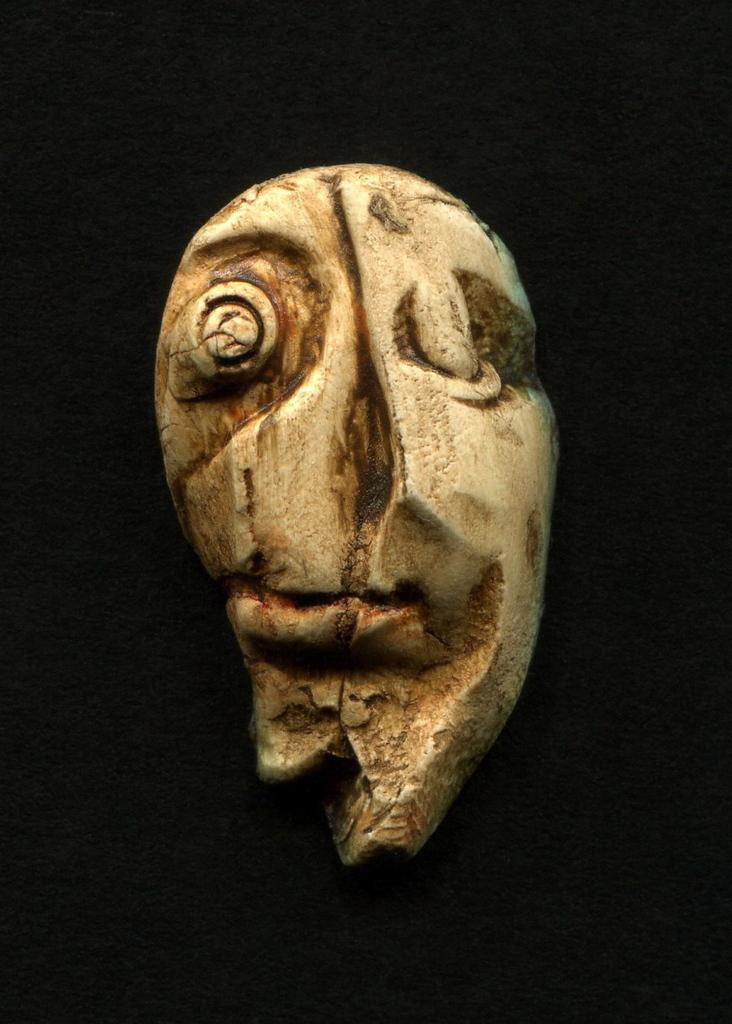What is the main subject of the image? There is a sculpture in the image. What can be observed about the background of the image? The background of the image is dark. How does the sculpture help in adjusting the brake system in the image? There is no mention of a brake system or any adjustments in the image; it only features a sculpture and a dark background. 